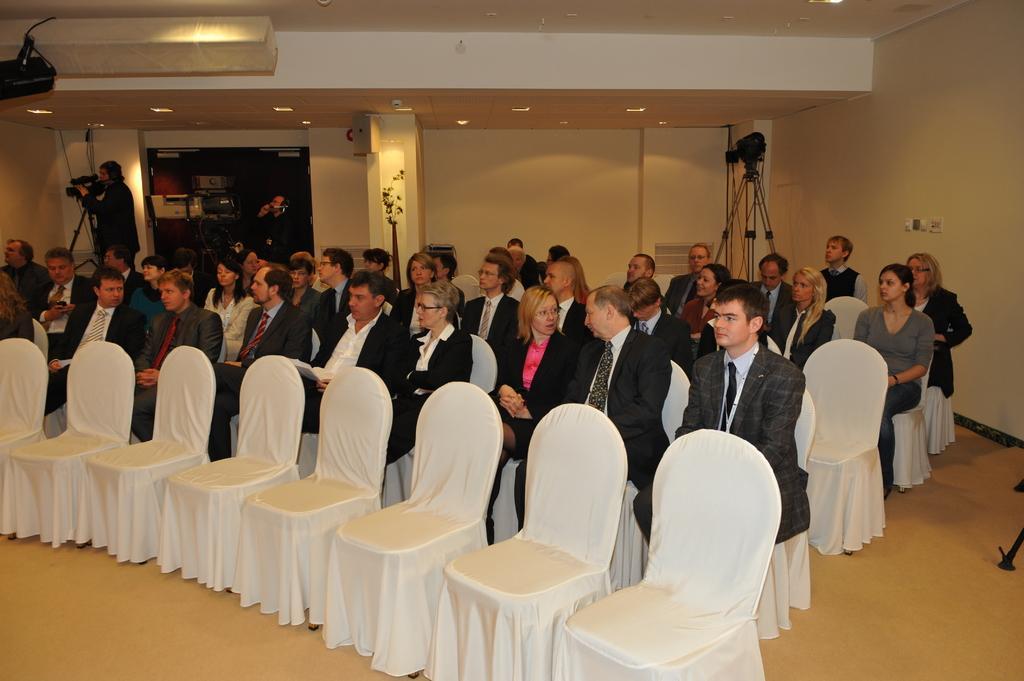Describe this image in one or two sentences. This is a hall. On the background we can see a wall,lights and few persons standing and recording. Here we can see a camera with stand. here we can see all the persons sitting on the chairs. These are empty chairs. This is a floor. 